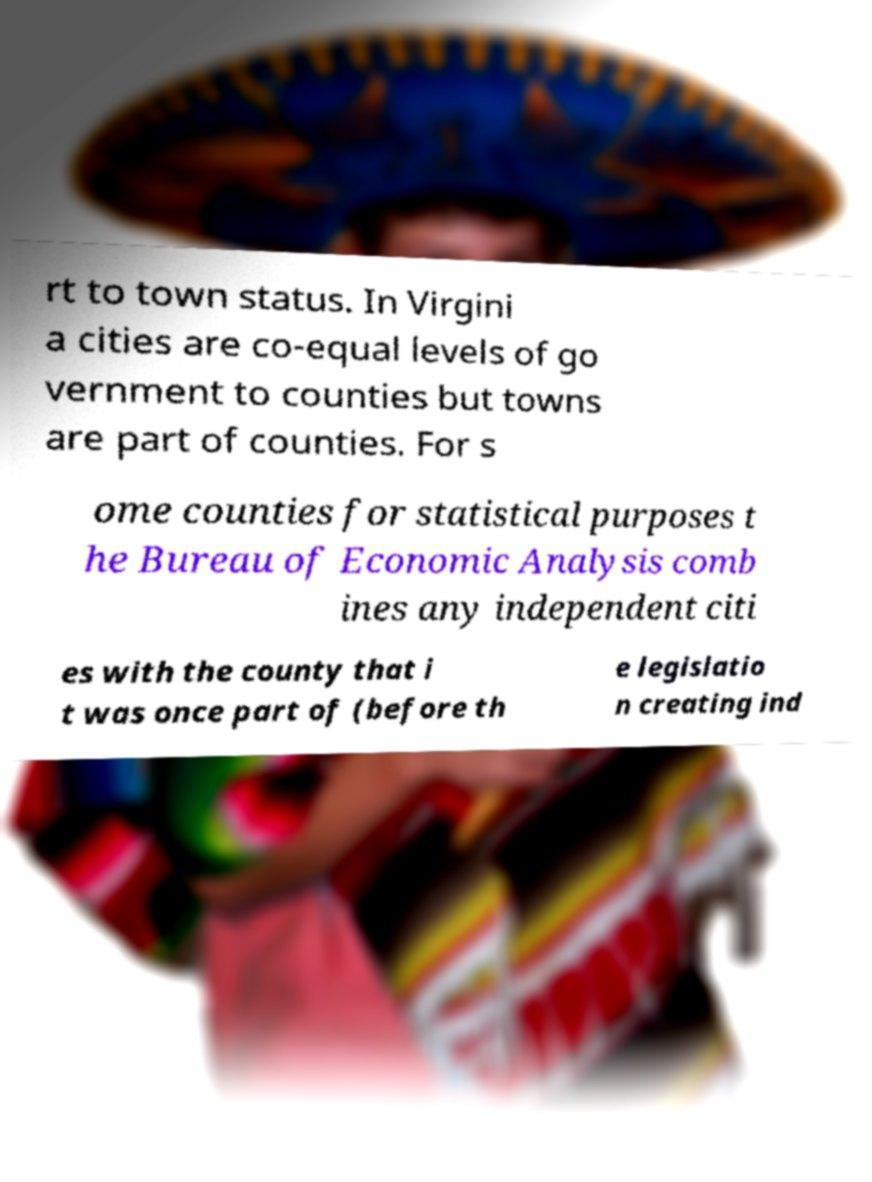Could you extract and type out the text from this image? rt to town status. In Virgini a cities are co-equal levels of go vernment to counties but towns are part of counties. For s ome counties for statistical purposes t he Bureau of Economic Analysis comb ines any independent citi es with the county that i t was once part of (before th e legislatio n creating ind 